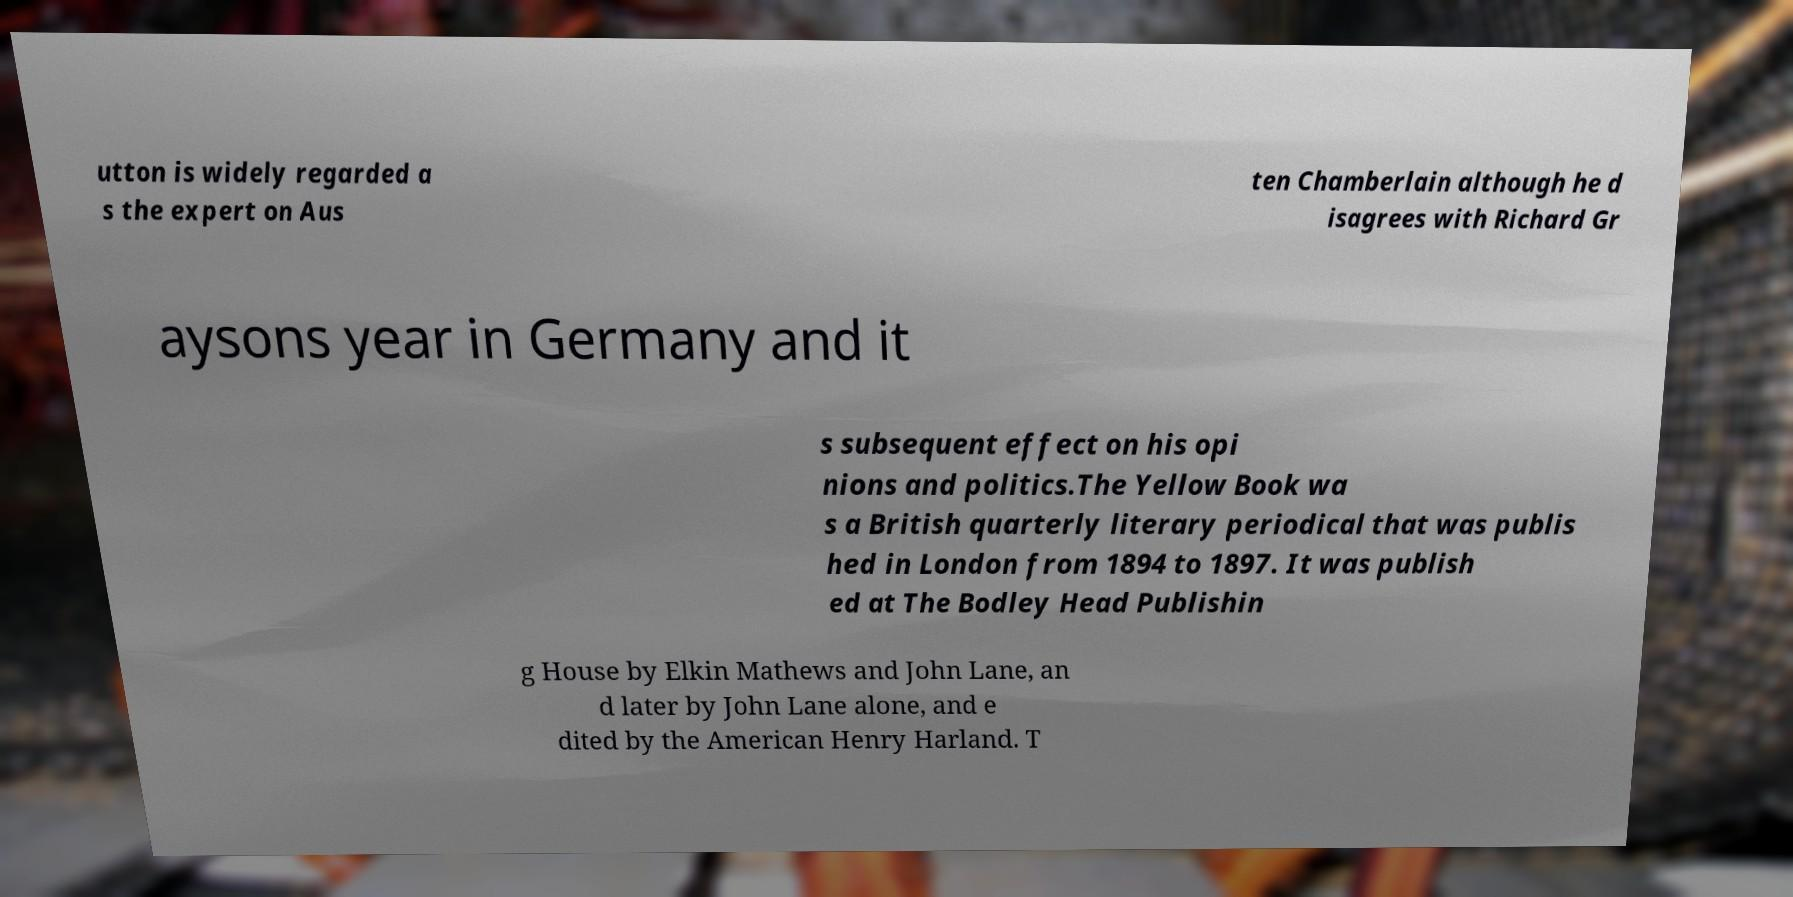I need the written content from this picture converted into text. Can you do that? utton is widely regarded a s the expert on Aus ten Chamberlain although he d isagrees with Richard Gr aysons year in Germany and it s subsequent effect on his opi nions and politics.The Yellow Book wa s a British quarterly literary periodical that was publis hed in London from 1894 to 1897. It was publish ed at The Bodley Head Publishin g House by Elkin Mathews and John Lane, an d later by John Lane alone, and e dited by the American Henry Harland. T 